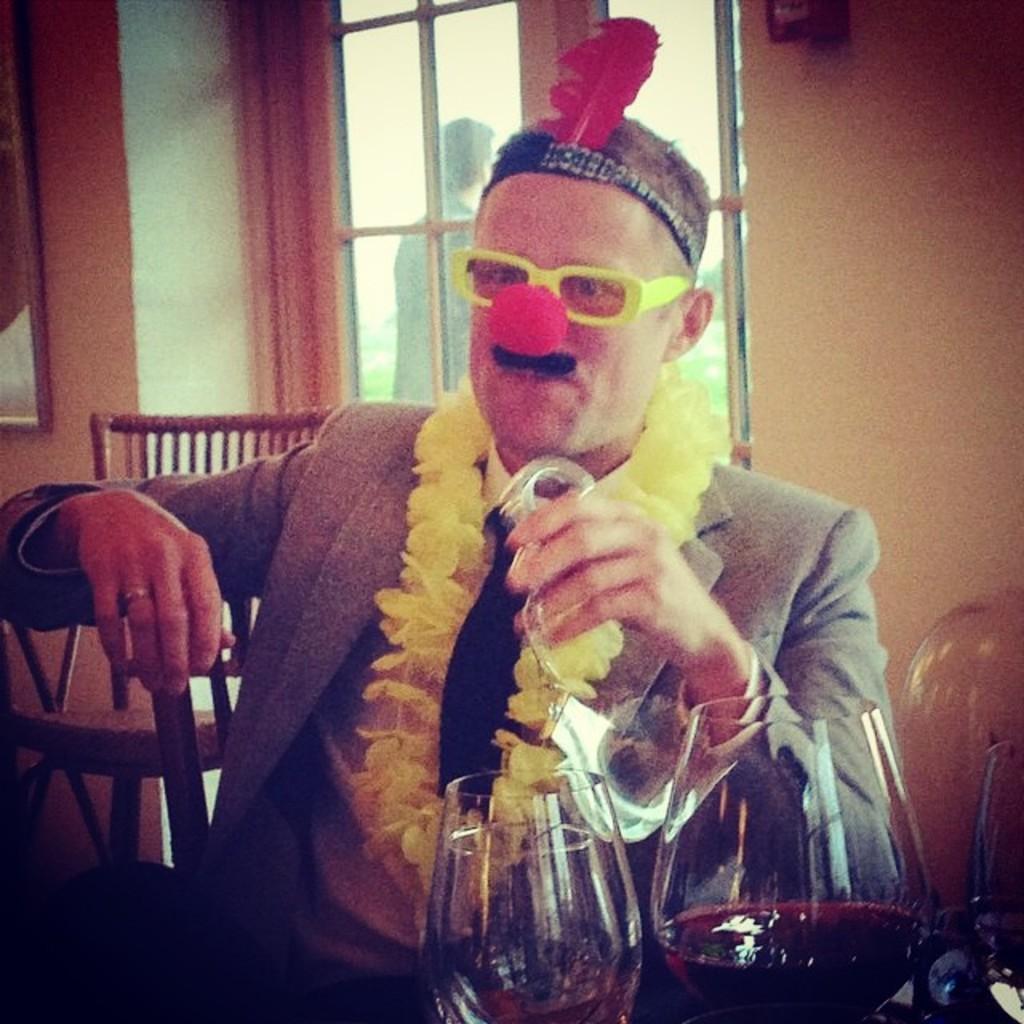Could you give a brief overview of what you see in this image? In this image there is a person sitting on the chair and he is in different costume, he is holding an object in his hand. In front of the person there are glasses and a few other objects, behind the person there is an empty chair. In the background there is a wall and a glass window. From the window we can see there is a person standing. 